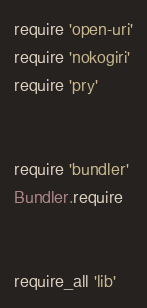Convert code to text. <code><loc_0><loc_0><loc_500><loc_500><_Ruby_>require 'open-uri'
require 'nokogiri'
require 'pry'


require 'bundler'
Bundler.require


require_all 'lib'





</code> 